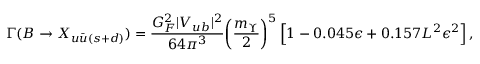Convert formula to latex. <formula><loc_0><loc_0><loc_500><loc_500>\Gamma ( B \to X _ { u \bar { u } ( s + d ) } ) = { \frac { G _ { F } ^ { 2 } | V _ { u b } | ^ { 2 } } { 6 4 \pi ^ { 3 } } } \left ( { \frac { m _ { \Upsilon } } { 2 } } \right ) ^ { 5 } \, \left [ 1 - 0 . 0 4 5 \epsilon + 0 . 1 5 7 L ^ { 2 } \epsilon ^ { 2 } \right ] \, ,</formula> 